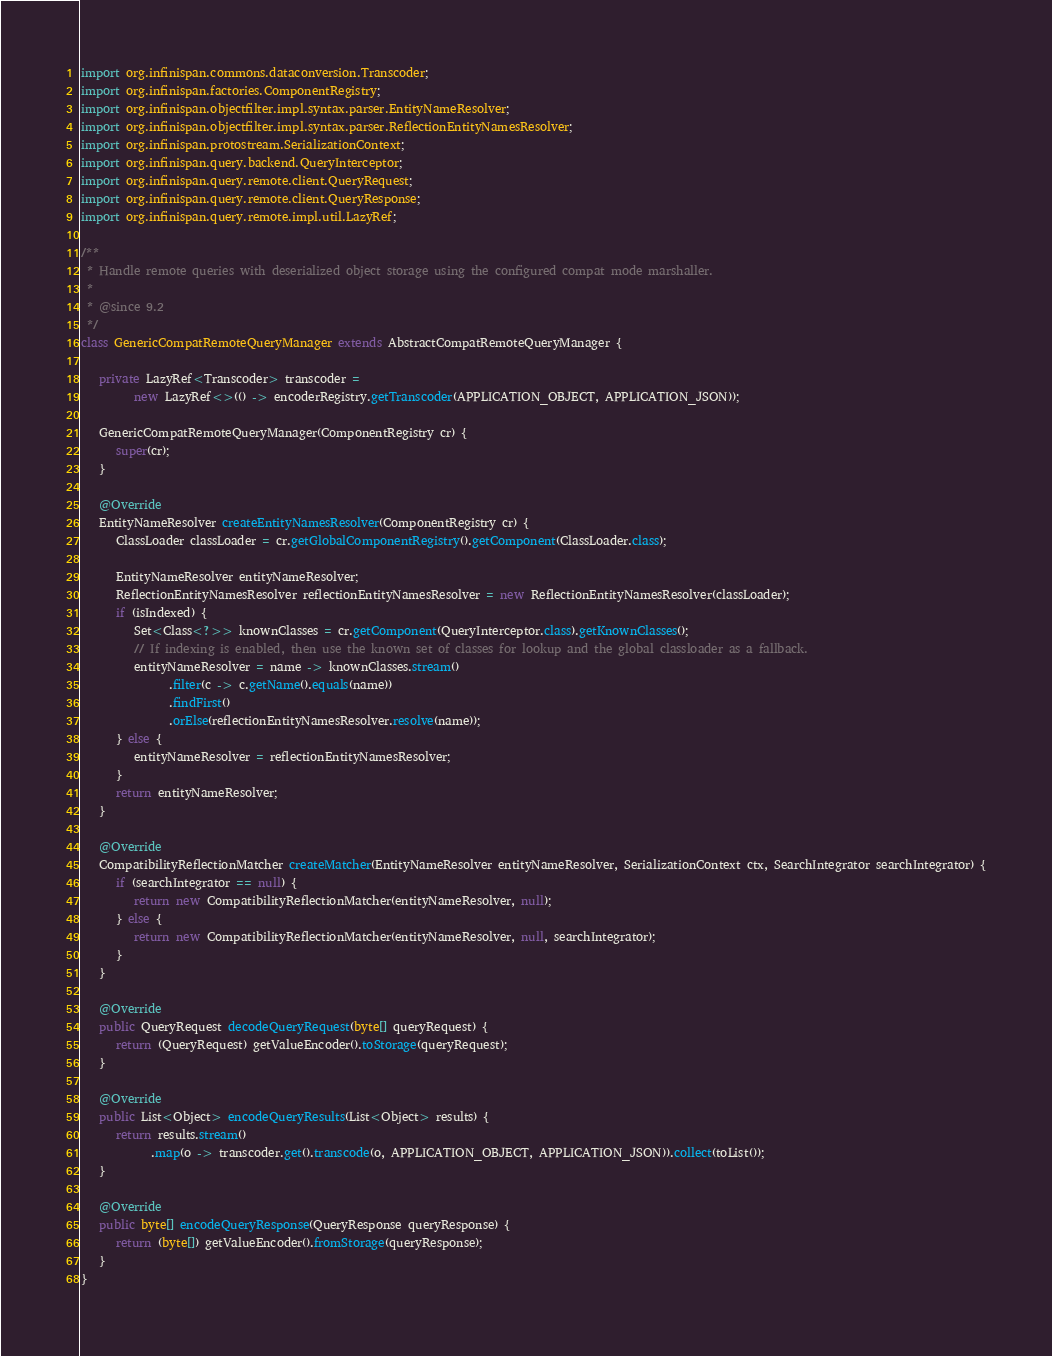Convert code to text. <code><loc_0><loc_0><loc_500><loc_500><_Java_>import org.infinispan.commons.dataconversion.Transcoder;
import org.infinispan.factories.ComponentRegistry;
import org.infinispan.objectfilter.impl.syntax.parser.EntityNameResolver;
import org.infinispan.objectfilter.impl.syntax.parser.ReflectionEntityNamesResolver;
import org.infinispan.protostream.SerializationContext;
import org.infinispan.query.backend.QueryInterceptor;
import org.infinispan.query.remote.client.QueryRequest;
import org.infinispan.query.remote.client.QueryResponse;
import org.infinispan.query.remote.impl.util.LazyRef;

/**
 * Handle remote queries with deserialized object storage using the configured compat mode marshaller.
 *
 * @since 9.2
 */
class GenericCompatRemoteQueryManager extends AbstractCompatRemoteQueryManager {

   private LazyRef<Transcoder> transcoder =
         new LazyRef<>(() -> encoderRegistry.getTranscoder(APPLICATION_OBJECT, APPLICATION_JSON));

   GenericCompatRemoteQueryManager(ComponentRegistry cr) {
      super(cr);
   }

   @Override
   EntityNameResolver createEntityNamesResolver(ComponentRegistry cr) {
      ClassLoader classLoader = cr.getGlobalComponentRegistry().getComponent(ClassLoader.class);

      EntityNameResolver entityNameResolver;
      ReflectionEntityNamesResolver reflectionEntityNamesResolver = new ReflectionEntityNamesResolver(classLoader);
      if (isIndexed) {
         Set<Class<?>> knownClasses = cr.getComponent(QueryInterceptor.class).getKnownClasses();
         // If indexing is enabled, then use the known set of classes for lookup and the global classloader as a fallback.
         entityNameResolver = name -> knownClasses.stream()
               .filter(c -> c.getName().equals(name))
               .findFirst()
               .orElse(reflectionEntityNamesResolver.resolve(name));
      } else {
         entityNameResolver = reflectionEntityNamesResolver;
      }
      return entityNameResolver;
   }

   @Override
   CompatibilityReflectionMatcher createMatcher(EntityNameResolver entityNameResolver, SerializationContext ctx, SearchIntegrator searchIntegrator) {
      if (searchIntegrator == null) {
         return new CompatibilityReflectionMatcher(entityNameResolver, null);
      } else {
         return new CompatibilityReflectionMatcher(entityNameResolver, null, searchIntegrator);
      }
   }

   @Override
   public QueryRequest decodeQueryRequest(byte[] queryRequest) {
      return (QueryRequest) getValueEncoder().toStorage(queryRequest);
   }

   @Override
   public List<Object> encodeQueryResults(List<Object> results) {
      return results.stream()
            .map(o -> transcoder.get().transcode(o, APPLICATION_OBJECT, APPLICATION_JSON)).collect(toList());
   }

   @Override
   public byte[] encodeQueryResponse(QueryResponse queryResponse) {
      return (byte[]) getValueEncoder().fromStorage(queryResponse);
   }
}
</code> 